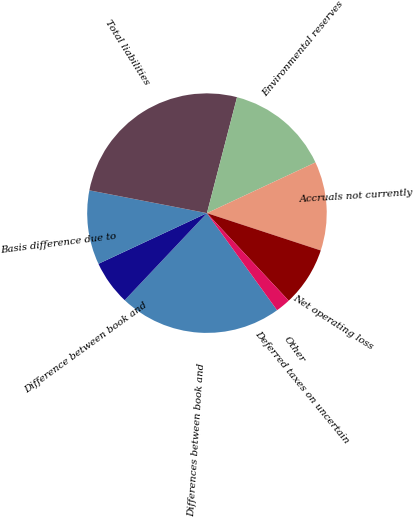Convert chart to OTSL. <chart><loc_0><loc_0><loc_500><loc_500><pie_chart><fcel>Differences between book and<fcel>Difference between book and<fcel>Basis difference due to<fcel>Total liabilities<fcel>Environmental reserves<fcel>Accruals not currently<fcel>Net operating loss<fcel>Deferred taxes on uncertain<fcel>Other<nl><fcel>22.0%<fcel>6.0%<fcel>10.0%<fcel>25.99%<fcel>14.0%<fcel>12.0%<fcel>8.0%<fcel>2.0%<fcel>0.0%<nl></chart> 